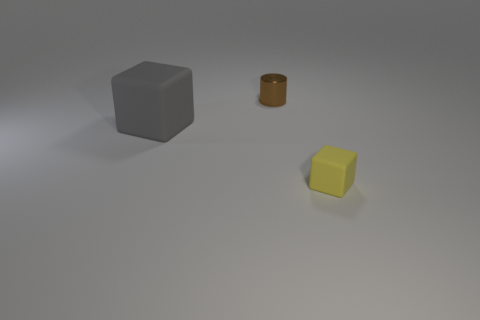Add 1 large gray things. How many objects exist? 4 Subtract all blocks. How many objects are left? 1 Subtract all red spheres. How many yellow cubes are left? 1 Subtract all gray blocks. How many blocks are left? 1 Subtract 0 red balls. How many objects are left? 3 Subtract all blue cubes. Subtract all red cylinders. How many cubes are left? 2 Subtract all cubes. Subtract all big cubes. How many objects are left? 0 Add 3 small cylinders. How many small cylinders are left? 4 Add 1 tiny metal objects. How many tiny metal objects exist? 2 